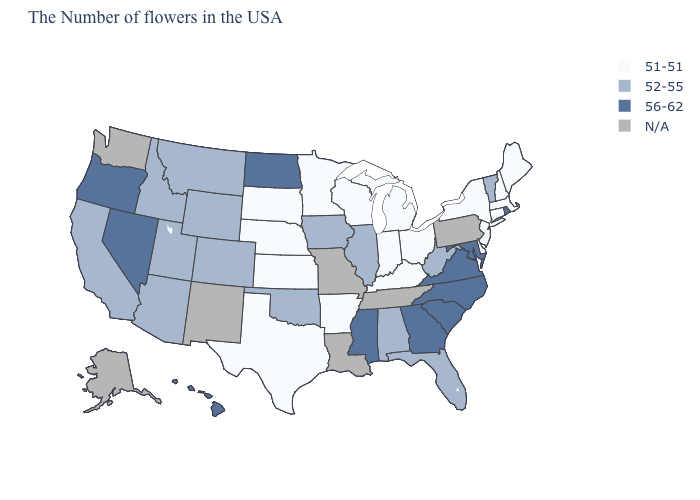Which states hav the highest value in the MidWest?
Answer briefly. North Dakota. Among the states that border Michigan , which have the lowest value?
Give a very brief answer. Ohio, Indiana, Wisconsin. What is the value of New York?
Concise answer only. 51-51. What is the highest value in the USA?
Concise answer only. 56-62. Does the map have missing data?
Keep it brief. Yes. Name the states that have a value in the range 56-62?
Give a very brief answer. Rhode Island, Maryland, Virginia, North Carolina, South Carolina, Georgia, Mississippi, North Dakota, Nevada, Oregon, Hawaii. Name the states that have a value in the range 51-51?
Answer briefly. Maine, Massachusetts, New Hampshire, Connecticut, New York, New Jersey, Delaware, Ohio, Michigan, Kentucky, Indiana, Wisconsin, Arkansas, Minnesota, Kansas, Nebraska, Texas, South Dakota. Does the first symbol in the legend represent the smallest category?
Answer briefly. Yes. What is the value of New York?
Quick response, please. 51-51. Does Hawaii have the highest value in the USA?
Quick response, please. Yes. What is the lowest value in the MidWest?
Concise answer only. 51-51. What is the value of Maryland?
Write a very short answer. 56-62. 